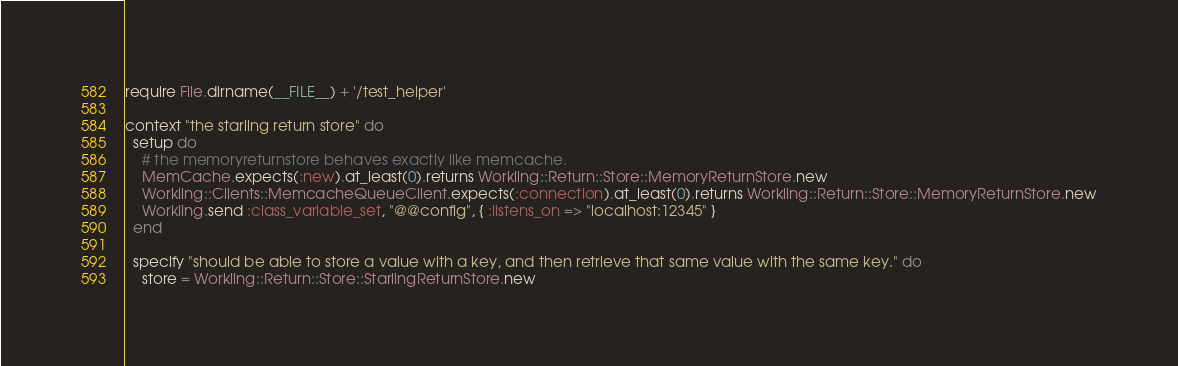<code> <loc_0><loc_0><loc_500><loc_500><_Ruby_>require File.dirname(__FILE__) + '/test_helper'

context "the starling return store" do
  setup do
    # the memoryreturnstore behaves exactly like memcache. 
    MemCache.expects(:new).at_least(0).returns Workling::Return::Store::MemoryReturnStore.new
    Workling::Clients::MemcacheQueueClient.expects(:connection).at_least(0).returns Workling::Return::Store::MemoryReturnStore.new
    Workling.send :class_variable_set, "@@config", { :listens_on => "localhost:12345" }
  end
  
  specify "should be able to store a value with a key, and then retrieve that same value with the same key." do
    store = Workling::Return::Store::StarlingReturnStore.new</code> 